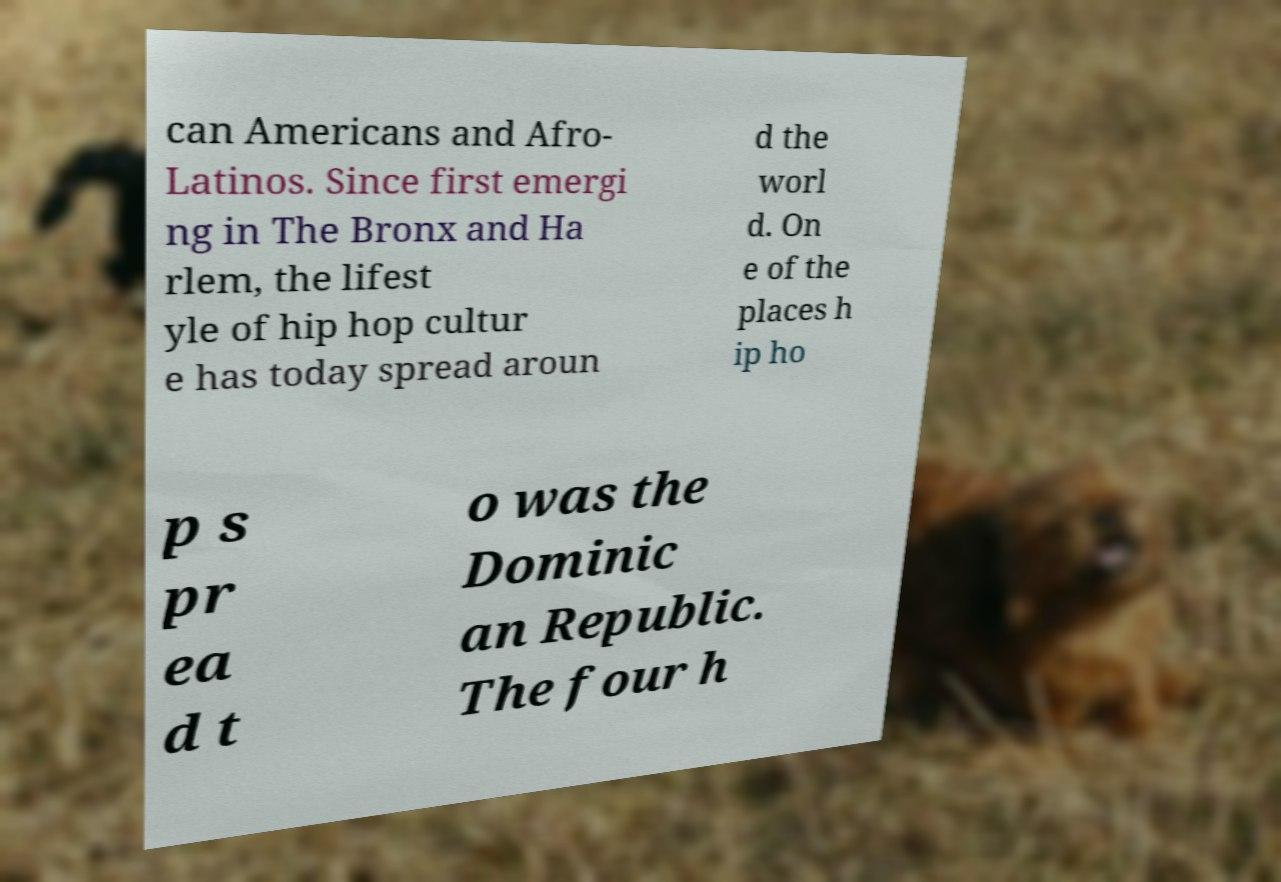Please read and relay the text visible in this image. What does it say? can Americans and Afro- Latinos. Since first emergi ng in The Bronx and Ha rlem, the lifest yle of hip hop cultur e has today spread aroun d the worl d. On e of the places h ip ho p s pr ea d t o was the Dominic an Republic. The four h 